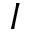<formula> <loc_0><loc_0><loc_500><loc_500>I</formula> 